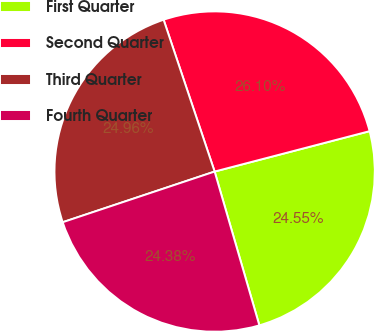Convert chart to OTSL. <chart><loc_0><loc_0><loc_500><loc_500><pie_chart><fcel>First Quarter<fcel>Second Quarter<fcel>Third Quarter<fcel>Fourth Quarter<nl><fcel>24.55%<fcel>26.1%<fcel>24.96%<fcel>24.38%<nl></chart> 